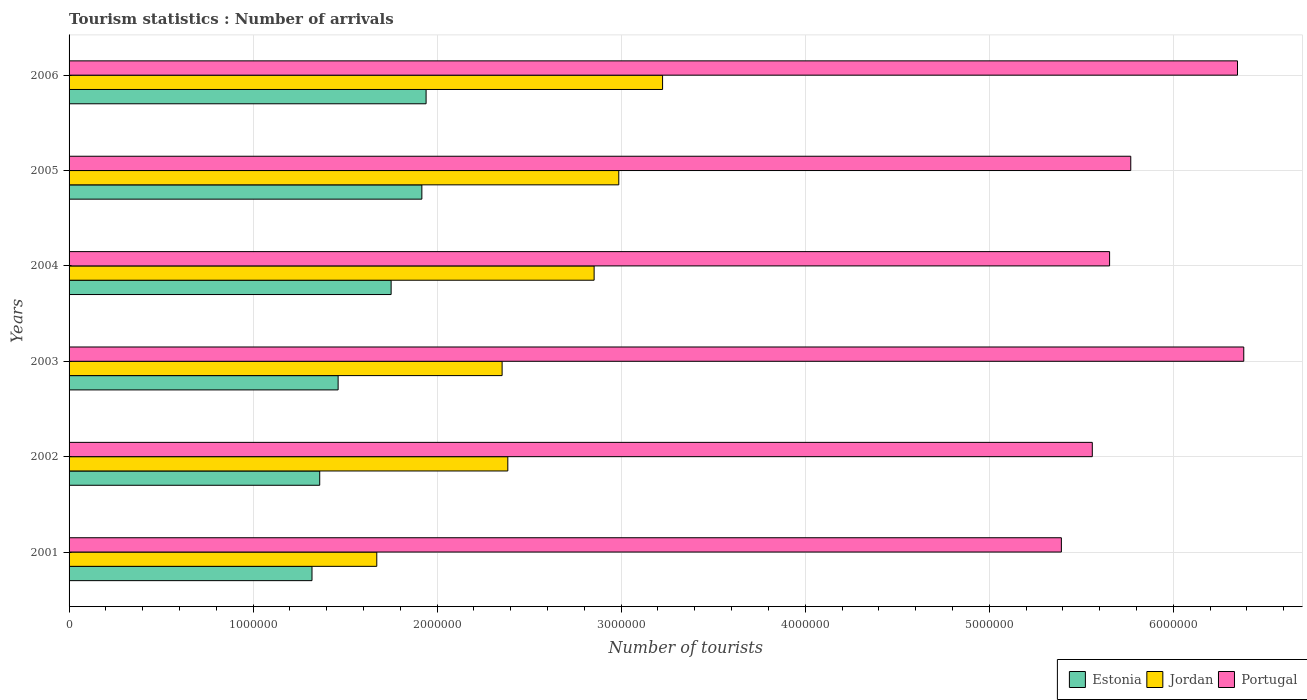How many different coloured bars are there?
Your response must be concise. 3. Are the number of bars on each tick of the Y-axis equal?
Your answer should be compact. Yes. How many bars are there on the 2nd tick from the top?
Your answer should be compact. 3. How many bars are there on the 2nd tick from the bottom?
Keep it short and to the point. 3. What is the number of tourist arrivals in Estonia in 2004?
Give a very brief answer. 1.75e+06. Across all years, what is the maximum number of tourist arrivals in Jordan?
Offer a very short reply. 3.22e+06. Across all years, what is the minimum number of tourist arrivals in Estonia?
Keep it short and to the point. 1.32e+06. In which year was the number of tourist arrivals in Jordan maximum?
Offer a very short reply. 2006. In which year was the number of tourist arrivals in Jordan minimum?
Provide a short and direct response. 2001. What is the total number of tourist arrivals in Estonia in the graph?
Provide a succinct answer. 9.75e+06. What is the difference between the number of tourist arrivals in Portugal in 2003 and that in 2005?
Make the answer very short. 6.14e+05. What is the difference between the number of tourist arrivals in Estonia in 2005 and the number of tourist arrivals in Jordan in 2003?
Keep it short and to the point. -4.36e+05. What is the average number of tourist arrivals in Estonia per year?
Keep it short and to the point. 1.63e+06. In the year 2006, what is the difference between the number of tourist arrivals in Estonia and number of tourist arrivals in Jordan?
Your answer should be compact. -1.28e+06. In how many years, is the number of tourist arrivals in Estonia greater than 3600000 ?
Make the answer very short. 0. What is the ratio of the number of tourist arrivals in Jordan in 2002 to that in 2004?
Ensure brevity in your answer.  0.84. What is the difference between the highest and the second highest number of tourist arrivals in Portugal?
Offer a very short reply. 3.40e+04. What is the difference between the highest and the lowest number of tourist arrivals in Estonia?
Your response must be concise. 6.20e+05. What does the 1st bar from the bottom in 2003 represents?
Your response must be concise. Estonia. How many bars are there?
Ensure brevity in your answer.  18. Does the graph contain any zero values?
Offer a very short reply. No. How many legend labels are there?
Offer a terse response. 3. How are the legend labels stacked?
Make the answer very short. Horizontal. What is the title of the graph?
Keep it short and to the point. Tourism statistics : Number of arrivals. What is the label or title of the X-axis?
Your response must be concise. Number of tourists. What is the label or title of the Y-axis?
Make the answer very short. Years. What is the Number of tourists in Estonia in 2001?
Offer a very short reply. 1.32e+06. What is the Number of tourists of Jordan in 2001?
Give a very brief answer. 1.67e+06. What is the Number of tourists of Portugal in 2001?
Ensure brevity in your answer.  5.39e+06. What is the Number of tourists of Estonia in 2002?
Your answer should be compact. 1.36e+06. What is the Number of tourists in Jordan in 2002?
Your answer should be compact. 2.38e+06. What is the Number of tourists in Portugal in 2002?
Your answer should be compact. 5.56e+06. What is the Number of tourists in Estonia in 2003?
Keep it short and to the point. 1.46e+06. What is the Number of tourists of Jordan in 2003?
Ensure brevity in your answer.  2.35e+06. What is the Number of tourists in Portugal in 2003?
Offer a terse response. 6.38e+06. What is the Number of tourists in Estonia in 2004?
Your response must be concise. 1.75e+06. What is the Number of tourists in Jordan in 2004?
Provide a short and direct response. 2.85e+06. What is the Number of tourists of Portugal in 2004?
Make the answer very short. 5.65e+06. What is the Number of tourists of Estonia in 2005?
Ensure brevity in your answer.  1.92e+06. What is the Number of tourists of Jordan in 2005?
Your response must be concise. 2.99e+06. What is the Number of tourists in Portugal in 2005?
Your answer should be very brief. 5.77e+06. What is the Number of tourists in Estonia in 2006?
Offer a terse response. 1.94e+06. What is the Number of tourists in Jordan in 2006?
Your answer should be compact. 3.22e+06. What is the Number of tourists of Portugal in 2006?
Provide a short and direct response. 6.35e+06. Across all years, what is the maximum Number of tourists in Estonia?
Your response must be concise. 1.94e+06. Across all years, what is the maximum Number of tourists of Jordan?
Offer a very short reply. 3.22e+06. Across all years, what is the maximum Number of tourists of Portugal?
Ensure brevity in your answer.  6.38e+06. Across all years, what is the minimum Number of tourists of Estonia?
Your response must be concise. 1.32e+06. Across all years, what is the minimum Number of tourists of Jordan?
Offer a very short reply. 1.67e+06. Across all years, what is the minimum Number of tourists in Portugal?
Your response must be concise. 5.39e+06. What is the total Number of tourists in Estonia in the graph?
Keep it short and to the point. 9.75e+06. What is the total Number of tourists of Jordan in the graph?
Your answer should be very brief. 1.55e+07. What is the total Number of tourists of Portugal in the graph?
Your answer should be very brief. 3.51e+07. What is the difference between the Number of tourists in Estonia in 2001 and that in 2002?
Provide a succinct answer. -4.20e+04. What is the difference between the Number of tourists of Jordan in 2001 and that in 2002?
Give a very brief answer. -7.12e+05. What is the difference between the Number of tourists of Portugal in 2001 and that in 2002?
Offer a very short reply. -1.68e+05. What is the difference between the Number of tourists in Estonia in 2001 and that in 2003?
Keep it short and to the point. -1.42e+05. What is the difference between the Number of tourists of Jordan in 2001 and that in 2003?
Provide a short and direct response. -6.81e+05. What is the difference between the Number of tourists in Portugal in 2001 and that in 2003?
Offer a terse response. -9.91e+05. What is the difference between the Number of tourists in Estonia in 2001 and that in 2004?
Offer a very short reply. -4.30e+05. What is the difference between the Number of tourists of Jordan in 2001 and that in 2004?
Ensure brevity in your answer.  -1.18e+06. What is the difference between the Number of tourists of Portugal in 2001 and that in 2004?
Ensure brevity in your answer.  -2.62e+05. What is the difference between the Number of tourists in Estonia in 2001 and that in 2005?
Offer a very short reply. -5.97e+05. What is the difference between the Number of tourists in Jordan in 2001 and that in 2005?
Offer a terse response. -1.32e+06. What is the difference between the Number of tourists in Portugal in 2001 and that in 2005?
Provide a succinct answer. -3.77e+05. What is the difference between the Number of tourists of Estonia in 2001 and that in 2006?
Offer a terse response. -6.20e+05. What is the difference between the Number of tourists of Jordan in 2001 and that in 2006?
Ensure brevity in your answer.  -1.55e+06. What is the difference between the Number of tourists of Portugal in 2001 and that in 2006?
Your answer should be very brief. -9.57e+05. What is the difference between the Number of tourists of Jordan in 2002 and that in 2003?
Keep it short and to the point. 3.10e+04. What is the difference between the Number of tourists in Portugal in 2002 and that in 2003?
Make the answer very short. -8.23e+05. What is the difference between the Number of tourists in Estonia in 2002 and that in 2004?
Provide a short and direct response. -3.88e+05. What is the difference between the Number of tourists of Jordan in 2002 and that in 2004?
Offer a terse response. -4.69e+05. What is the difference between the Number of tourists of Portugal in 2002 and that in 2004?
Your answer should be very brief. -9.40e+04. What is the difference between the Number of tourists of Estonia in 2002 and that in 2005?
Give a very brief answer. -5.55e+05. What is the difference between the Number of tourists in Jordan in 2002 and that in 2005?
Provide a succinct answer. -6.03e+05. What is the difference between the Number of tourists of Portugal in 2002 and that in 2005?
Provide a succinct answer. -2.09e+05. What is the difference between the Number of tourists of Estonia in 2002 and that in 2006?
Offer a terse response. -5.78e+05. What is the difference between the Number of tourists of Jordan in 2002 and that in 2006?
Offer a very short reply. -8.41e+05. What is the difference between the Number of tourists in Portugal in 2002 and that in 2006?
Give a very brief answer. -7.89e+05. What is the difference between the Number of tourists of Estonia in 2003 and that in 2004?
Make the answer very short. -2.88e+05. What is the difference between the Number of tourists in Jordan in 2003 and that in 2004?
Your answer should be compact. -5.00e+05. What is the difference between the Number of tourists in Portugal in 2003 and that in 2004?
Give a very brief answer. 7.29e+05. What is the difference between the Number of tourists in Estonia in 2003 and that in 2005?
Offer a terse response. -4.55e+05. What is the difference between the Number of tourists of Jordan in 2003 and that in 2005?
Offer a very short reply. -6.34e+05. What is the difference between the Number of tourists in Portugal in 2003 and that in 2005?
Your answer should be very brief. 6.14e+05. What is the difference between the Number of tourists of Estonia in 2003 and that in 2006?
Ensure brevity in your answer.  -4.78e+05. What is the difference between the Number of tourists of Jordan in 2003 and that in 2006?
Ensure brevity in your answer.  -8.72e+05. What is the difference between the Number of tourists of Portugal in 2003 and that in 2006?
Keep it short and to the point. 3.40e+04. What is the difference between the Number of tourists in Estonia in 2004 and that in 2005?
Offer a very short reply. -1.67e+05. What is the difference between the Number of tourists in Jordan in 2004 and that in 2005?
Your answer should be very brief. -1.34e+05. What is the difference between the Number of tourists of Portugal in 2004 and that in 2005?
Ensure brevity in your answer.  -1.15e+05. What is the difference between the Number of tourists of Jordan in 2004 and that in 2006?
Your response must be concise. -3.72e+05. What is the difference between the Number of tourists of Portugal in 2004 and that in 2006?
Your answer should be very brief. -6.95e+05. What is the difference between the Number of tourists in Estonia in 2005 and that in 2006?
Ensure brevity in your answer.  -2.30e+04. What is the difference between the Number of tourists in Jordan in 2005 and that in 2006?
Make the answer very short. -2.38e+05. What is the difference between the Number of tourists in Portugal in 2005 and that in 2006?
Make the answer very short. -5.80e+05. What is the difference between the Number of tourists of Estonia in 2001 and the Number of tourists of Jordan in 2002?
Make the answer very short. -1.06e+06. What is the difference between the Number of tourists in Estonia in 2001 and the Number of tourists in Portugal in 2002?
Keep it short and to the point. -4.24e+06. What is the difference between the Number of tourists of Jordan in 2001 and the Number of tourists of Portugal in 2002?
Your answer should be compact. -3.89e+06. What is the difference between the Number of tourists in Estonia in 2001 and the Number of tourists in Jordan in 2003?
Offer a terse response. -1.03e+06. What is the difference between the Number of tourists in Estonia in 2001 and the Number of tourists in Portugal in 2003?
Provide a succinct answer. -5.06e+06. What is the difference between the Number of tourists of Jordan in 2001 and the Number of tourists of Portugal in 2003?
Offer a terse response. -4.71e+06. What is the difference between the Number of tourists of Estonia in 2001 and the Number of tourists of Jordan in 2004?
Give a very brief answer. -1.53e+06. What is the difference between the Number of tourists of Estonia in 2001 and the Number of tourists of Portugal in 2004?
Your answer should be compact. -4.33e+06. What is the difference between the Number of tourists in Jordan in 2001 and the Number of tourists in Portugal in 2004?
Offer a terse response. -3.98e+06. What is the difference between the Number of tourists of Estonia in 2001 and the Number of tourists of Jordan in 2005?
Offer a terse response. -1.67e+06. What is the difference between the Number of tourists of Estonia in 2001 and the Number of tourists of Portugal in 2005?
Keep it short and to the point. -4.45e+06. What is the difference between the Number of tourists in Jordan in 2001 and the Number of tourists in Portugal in 2005?
Ensure brevity in your answer.  -4.10e+06. What is the difference between the Number of tourists in Estonia in 2001 and the Number of tourists in Jordan in 2006?
Ensure brevity in your answer.  -1.90e+06. What is the difference between the Number of tourists of Estonia in 2001 and the Number of tourists of Portugal in 2006?
Make the answer very short. -5.03e+06. What is the difference between the Number of tourists of Jordan in 2001 and the Number of tourists of Portugal in 2006?
Give a very brief answer. -4.68e+06. What is the difference between the Number of tourists of Estonia in 2002 and the Number of tourists of Jordan in 2003?
Make the answer very short. -9.91e+05. What is the difference between the Number of tourists in Estonia in 2002 and the Number of tourists in Portugal in 2003?
Offer a very short reply. -5.02e+06. What is the difference between the Number of tourists of Jordan in 2002 and the Number of tourists of Portugal in 2003?
Your answer should be compact. -4.00e+06. What is the difference between the Number of tourists in Estonia in 2002 and the Number of tourists in Jordan in 2004?
Provide a succinct answer. -1.49e+06. What is the difference between the Number of tourists of Estonia in 2002 and the Number of tourists of Portugal in 2004?
Ensure brevity in your answer.  -4.29e+06. What is the difference between the Number of tourists in Jordan in 2002 and the Number of tourists in Portugal in 2004?
Your response must be concise. -3.27e+06. What is the difference between the Number of tourists in Estonia in 2002 and the Number of tourists in Jordan in 2005?
Offer a terse response. -1.62e+06. What is the difference between the Number of tourists of Estonia in 2002 and the Number of tourists of Portugal in 2005?
Provide a succinct answer. -4.41e+06. What is the difference between the Number of tourists in Jordan in 2002 and the Number of tourists in Portugal in 2005?
Provide a short and direct response. -3.38e+06. What is the difference between the Number of tourists in Estonia in 2002 and the Number of tourists in Jordan in 2006?
Make the answer very short. -1.86e+06. What is the difference between the Number of tourists in Estonia in 2002 and the Number of tourists in Portugal in 2006?
Give a very brief answer. -4.99e+06. What is the difference between the Number of tourists of Jordan in 2002 and the Number of tourists of Portugal in 2006?
Ensure brevity in your answer.  -3.96e+06. What is the difference between the Number of tourists of Estonia in 2003 and the Number of tourists of Jordan in 2004?
Provide a succinct answer. -1.39e+06. What is the difference between the Number of tourists in Estonia in 2003 and the Number of tourists in Portugal in 2004?
Offer a terse response. -4.19e+06. What is the difference between the Number of tourists in Jordan in 2003 and the Number of tourists in Portugal in 2004?
Keep it short and to the point. -3.30e+06. What is the difference between the Number of tourists in Estonia in 2003 and the Number of tourists in Jordan in 2005?
Provide a succinct answer. -1.52e+06. What is the difference between the Number of tourists of Estonia in 2003 and the Number of tourists of Portugal in 2005?
Your response must be concise. -4.31e+06. What is the difference between the Number of tourists in Jordan in 2003 and the Number of tourists in Portugal in 2005?
Your answer should be compact. -3.42e+06. What is the difference between the Number of tourists of Estonia in 2003 and the Number of tourists of Jordan in 2006?
Provide a succinct answer. -1.76e+06. What is the difference between the Number of tourists in Estonia in 2003 and the Number of tourists in Portugal in 2006?
Your answer should be compact. -4.89e+06. What is the difference between the Number of tourists in Jordan in 2003 and the Number of tourists in Portugal in 2006?
Your answer should be very brief. -4.00e+06. What is the difference between the Number of tourists of Estonia in 2004 and the Number of tourists of Jordan in 2005?
Keep it short and to the point. -1.24e+06. What is the difference between the Number of tourists in Estonia in 2004 and the Number of tourists in Portugal in 2005?
Offer a terse response. -4.02e+06. What is the difference between the Number of tourists of Jordan in 2004 and the Number of tourists of Portugal in 2005?
Your answer should be compact. -2.92e+06. What is the difference between the Number of tourists of Estonia in 2004 and the Number of tourists of Jordan in 2006?
Offer a very short reply. -1.48e+06. What is the difference between the Number of tourists of Estonia in 2004 and the Number of tourists of Portugal in 2006?
Make the answer very short. -4.60e+06. What is the difference between the Number of tourists in Jordan in 2004 and the Number of tourists in Portugal in 2006?
Give a very brief answer. -3.50e+06. What is the difference between the Number of tourists of Estonia in 2005 and the Number of tourists of Jordan in 2006?
Make the answer very short. -1.31e+06. What is the difference between the Number of tourists of Estonia in 2005 and the Number of tourists of Portugal in 2006?
Your answer should be compact. -4.43e+06. What is the difference between the Number of tourists in Jordan in 2005 and the Number of tourists in Portugal in 2006?
Make the answer very short. -3.36e+06. What is the average Number of tourists in Estonia per year?
Provide a succinct answer. 1.63e+06. What is the average Number of tourists in Jordan per year?
Offer a terse response. 2.58e+06. What is the average Number of tourists of Portugal per year?
Offer a terse response. 5.85e+06. In the year 2001, what is the difference between the Number of tourists of Estonia and Number of tourists of Jordan?
Ensure brevity in your answer.  -3.52e+05. In the year 2001, what is the difference between the Number of tourists in Estonia and Number of tourists in Portugal?
Your answer should be very brief. -4.07e+06. In the year 2001, what is the difference between the Number of tourists in Jordan and Number of tourists in Portugal?
Offer a terse response. -3.72e+06. In the year 2002, what is the difference between the Number of tourists in Estonia and Number of tourists in Jordan?
Ensure brevity in your answer.  -1.02e+06. In the year 2002, what is the difference between the Number of tourists of Estonia and Number of tourists of Portugal?
Your response must be concise. -4.20e+06. In the year 2002, what is the difference between the Number of tourists of Jordan and Number of tourists of Portugal?
Offer a very short reply. -3.18e+06. In the year 2003, what is the difference between the Number of tourists in Estonia and Number of tourists in Jordan?
Provide a short and direct response. -8.91e+05. In the year 2003, what is the difference between the Number of tourists in Estonia and Number of tourists in Portugal?
Your answer should be very brief. -4.92e+06. In the year 2003, what is the difference between the Number of tourists of Jordan and Number of tourists of Portugal?
Your answer should be very brief. -4.03e+06. In the year 2004, what is the difference between the Number of tourists of Estonia and Number of tourists of Jordan?
Offer a very short reply. -1.10e+06. In the year 2004, what is the difference between the Number of tourists in Estonia and Number of tourists in Portugal?
Provide a succinct answer. -3.90e+06. In the year 2004, what is the difference between the Number of tourists in Jordan and Number of tourists in Portugal?
Your response must be concise. -2.80e+06. In the year 2005, what is the difference between the Number of tourists in Estonia and Number of tourists in Jordan?
Your answer should be compact. -1.07e+06. In the year 2005, what is the difference between the Number of tourists of Estonia and Number of tourists of Portugal?
Give a very brief answer. -3.85e+06. In the year 2005, what is the difference between the Number of tourists in Jordan and Number of tourists in Portugal?
Give a very brief answer. -2.78e+06. In the year 2006, what is the difference between the Number of tourists of Estonia and Number of tourists of Jordan?
Provide a short and direct response. -1.28e+06. In the year 2006, what is the difference between the Number of tourists of Estonia and Number of tourists of Portugal?
Your answer should be very brief. -4.41e+06. In the year 2006, what is the difference between the Number of tourists in Jordan and Number of tourists in Portugal?
Ensure brevity in your answer.  -3.12e+06. What is the ratio of the Number of tourists in Estonia in 2001 to that in 2002?
Your answer should be very brief. 0.97. What is the ratio of the Number of tourists in Jordan in 2001 to that in 2002?
Provide a succinct answer. 0.7. What is the ratio of the Number of tourists of Portugal in 2001 to that in 2002?
Offer a very short reply. 0.97. What is the ratio of the Number of tourists in Estonia in 2001 to that in 2003?
Your response must be concise. 0.9. What is the ratio of the Number of tourists of Jordan in 2001 to that in 2003?
Provide a succinct answer. 0.71. What is the ratio of the Number of tourists of Portugal in 2001 to that in 2003?
Offer a terse response. 0.84. What is the ratio of the Number of tourists in Estonia in 2001 to that in 2004?
Ensure brevity in your answer.  0.75. What is the ratio of the Number of tourists in Jordan in 2001 to that in 2004?
Offer a terse response. 0.59. What is the ratio of the Number of tourists of Portugal in 2001 to that in 2004?
Your answer should be compact. 0.95. What is the ratio of the Number of tourists of Estonia in 2001 to that in 2005?
Provide a succinct answer. 0.69. What is the ratio of the Number of tourists in Jordan in 2001 to that in 2005?
Your answer should be compact. 0.56. What is the ratio of the Number of tourists of Portugal in 2001 to that in 2005?
Keep it short and to the point. 0.93. What is the ratio of the Number of tourists of Estonia in 2001 to that in 2006?
Your response must be concise. 0.68. What is the ratio of the Number of tourists of Jordan in 2001 to that in 2006?
Ensure brevity in your answer.  0.52. What is the ratio of the Number of tourists of Portugal in 2001 to that in 2006?
Your answer should be very brief. 0.85. What is the ratio of the Number of tourists in Estonia in 2002 to that in 2003?
Keep it short and to the point. 0.93. What is the ratio of the Number of tourists of Jordan in 2002 to that in 2003?
Keep it short and to the point. 1.01. What is the ratio of the Number of tourists in Portugal in 2002 to that in 2003?
Keep it short and to the point. 0.87. What is the ratio of the Number of tourists of Estonia in 2002 to that in 2004?
Offer a very short reply. 0.78. What is the ratio of the Number of tourists of Jordan in 2002 to that in 2004?
Your answer should be very brief. 0.84. What is the ratio of the Number of tourists in Portugal in 2002 to that in 2004?
Your response must be concise. 0.98. What is the ratio of the Number of tourists of Estonia in 2002 to that in 2005?
Ensure brevity in your answer.  0.71. What is the ratio of the Number of tourists of Jordan in 2002 to that in 2005?
Your answer should be very brief. 0.8. What is the ratio of the Number of tourists in Portugal in 2002 to that in 2005?
Provide a succinct answer. 0.96. What is the ratio of the Number of tourists of Estonia in 2002 to that in 2006?
Offer a terse response. 0.7. What is the ratio of the Number of tourists in Jordan in 2002 to that in 2006?
Your answer should be compact. 0.74. What is the ratio of the Number of tourists of Portugal in 2002 to that in 2006?
Make the answer very short. 0.88. What is the ratio of the Number of tourists in Estonia in 2003 to that in 2004?
Offer a terse response. 0.84. What is the ratio of the Number of tourists in Jordan in 2003 to that in 2004?
Offer a terse response. 0.82. What is the ratio of the Number of tourists of Portugal in 2003 to that in 2004?
Keep it short and to the point. 1.13. What is the ratio of the Number of tourists of Estonia in 2003 to that in 2005?
Ensure brevity in your answer.  0.76. What is the ratio of the Number of tourists in Jordan in 2003 to that in 2005?
Provide a short and direct response. 0.79. What is the ratio of the Number of tourists of Portugal in 2003 to that in 2005?
Your response must be concise. 1.11. What is the ratio of the Number of tourists in Estonia in 2003 to that in 2006?
Keep it short and to the point. 0.75. What is the ratio of the Number of tourists of Jordan in 2003 to that in 2006?
Your answer should be very brief. 0.73. What is the ratio of the Number of tourists in Portugal in 2003 to that in 2006?
Your answer should be compact. 1.01. What is the ratio of the Number of tourists of Estonia in 2004 to that in 2005?
Keep it short and to the point. 0.91. What is the ratio of the Number of tourists in Jordan in 2004 to that in 2005?
Provide a succinct answer. 0.96. What is the ratio of the Number of tourists in Portugal in 2004 to that in 2005?
Give a very brief answer. 0.98. What is the ratio of the Number of tourists of Estonia in 2004 to that in 2006?
Keep it short and to the point. 0.9. What is the ratio of the Number of tourists in Jordan in 2004 to that in 2006?
Offer a very short reply. 0.88. What is the ratio of the Number of tourists in Portugal in 2004 to that in 2006?
Make the answer very short. 0.89. What is the ratio of the Number of tourists of Jordan in 2005 to that in 2006?
Keep it short and to the point. 0.93. What is the ratio of the Number of tourists of Portugal in 2005 to that in 2006?
Keep it short and to the point. 0.91. What is the difference between the highest and the second highest Number of tourists in Estonia?
Offer a very short reply. 2.30e+04. What is the difference between the highest and the second highest Number of tourists of Jordan?
Keep it short and to the point. 2.38e+05. What is the difference between the highest and the second highest Number of tourists of Portugal?
Give a very brief answer. 3.40e+04. What is the difference between the highest and the lowest Number of tourists in Estonia?
Provide a short and direct response. 6.20e+05. What is the difference between the highest and the lowest Number of tourists of Jordan?
Your answer should be compact. 1.55e+06. What is the difference between the highest and the lowest Number of tourists of Portugal?
Make the answer very short. 9.91e+05. 